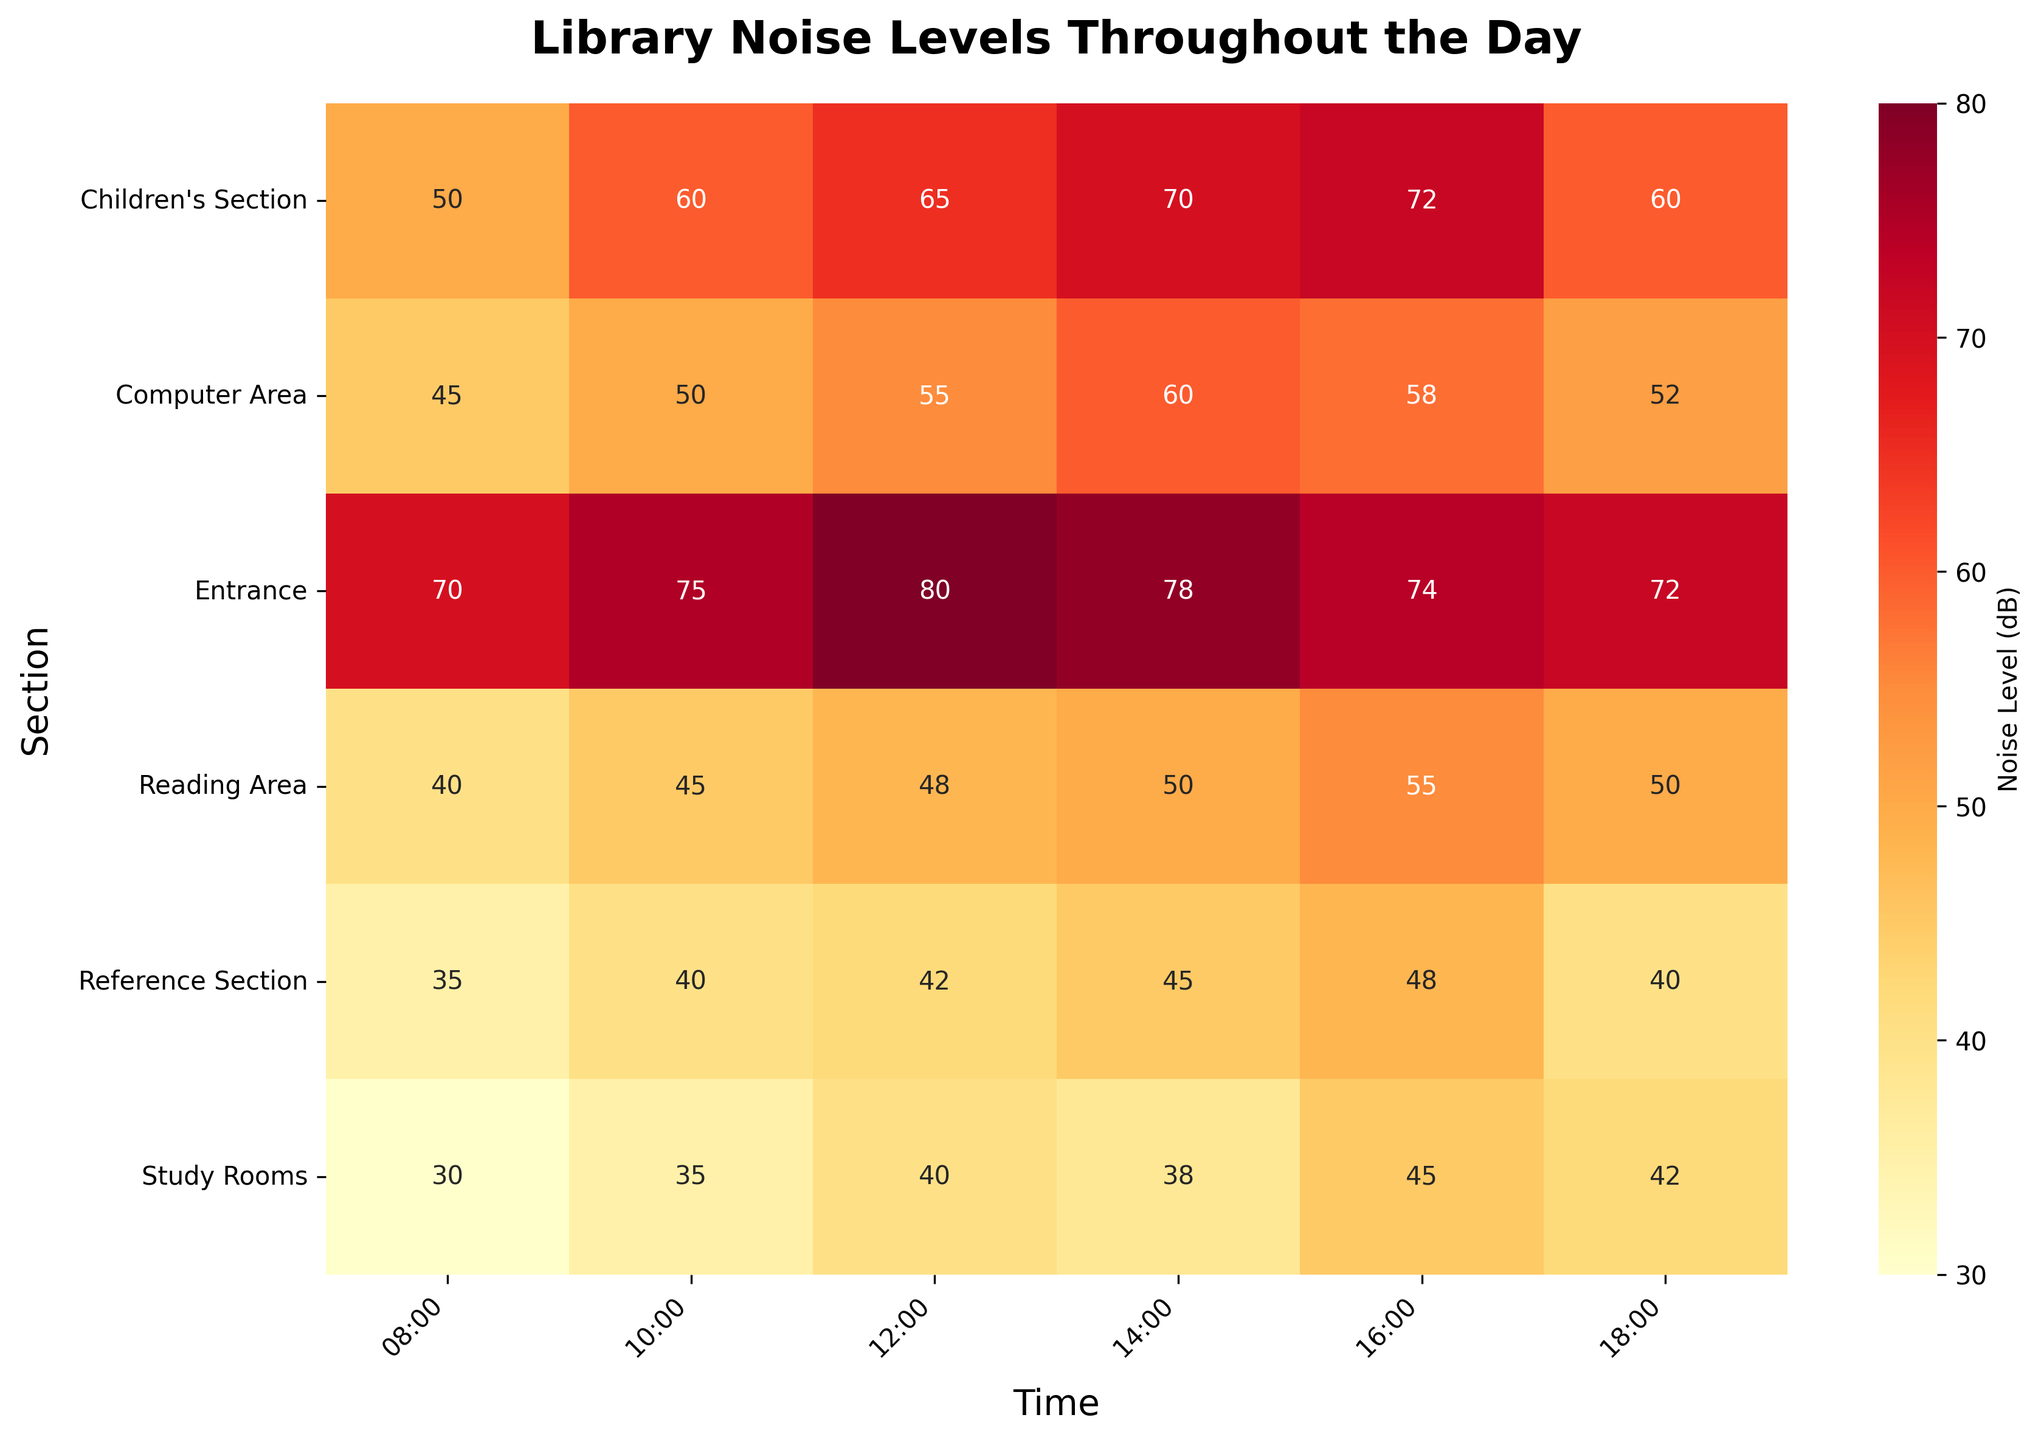What's the title of the heatmap? The text at the top of the heatmap displays the title.
Answer: Library Noise Levels Throughout the Day Which section has the highest noise level throughout the day? The darkest shade of red indicates the highest noise level on the heatmap. The Entrance section at 12:00 has the darkest shade.
Answer: Entrance at 12:00 Which section is the quietest at 08:00? The lightest shade of the color represents the lowest noise level. The Study Rooms section at 08:00 has the lightest shade.
Answer: Study Rooms What is the noise level in the Reading Area at 16:00? Locate the Reading Area row and the 16:00 column to find the noise levels.
Answer: 55 Compare the noise levels between the Children's Section and the Computer Area at 14:00. Which one is louder? Look for the values in the Children's Section row and the Computer Area row at 14:00. The Children's Section has 70 while the Computer Area has 60.
Answer: Children's Section Between which times does the Reference Section show an increase in noise level? Examine the Reference Section's row and identify the times and values. The noise level increases between 08:00 and 16:00.
Answer: 08:00 to 16:00 What’s the average noise level in the Study Rooms throughout the day? Add up all the noise levels at different times in the Study Rooms and divide by the number of times. (30 + 35 + 40 + 38 + 45 + 42)/6 = 38.33
Answer: 38.33 Which section experiences the most consistent noise level throughout the day? Identify the section where the noise levels show the least variation across the times. The Reference Section's noise levels range between 35 and 48, showing less variation compared to other sections.
Answer: Reference Section How does the noise level change in the Entrance from 10:00 to 14:00? Compare the values in the Entrance section between 10:00 and 14:00. The noise level increases from 75 to 78, then decreases to 74.
Answer: Increases then decreases What is the median noise level in the Children's Section throughout the day? List the noise levels in the Children's Section and find the middle value. (50, 60, 65, 70, 72, 60) - The median value is 65.
Answer: 65 What trends can you observe in noise levels across all sections at 12:00 and 18:00? Analyze the noise levels at 12:00 and 18:00 across all sections. At 12:00, most sections show higher noise levels, while at 18:00, noise levels seem to decrease overall.
Answer: Noise tends to decrease at 18:00 